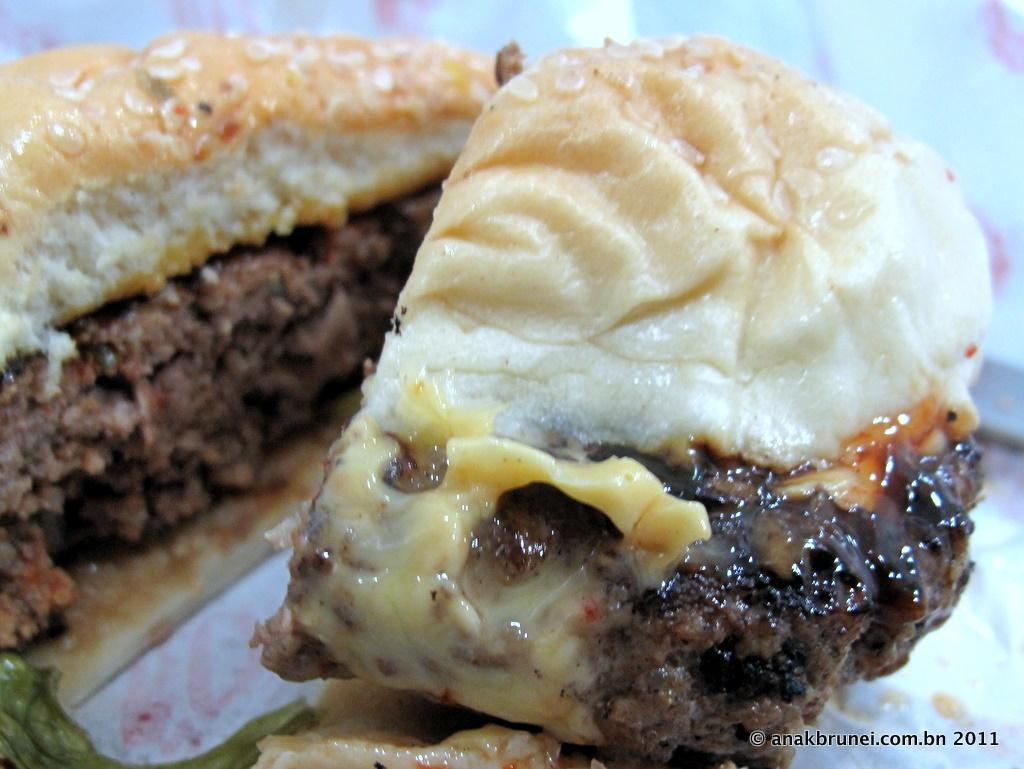What object is present on the plate in the image? There is a food item on the plate in the image. Can you describe the text in the bottom right corner of the image? There is text in the bottom right corner of the image. What activity are the bears engaged in on the plate in the image? There are no bears present in the image, so it is not possible to answer that question. 